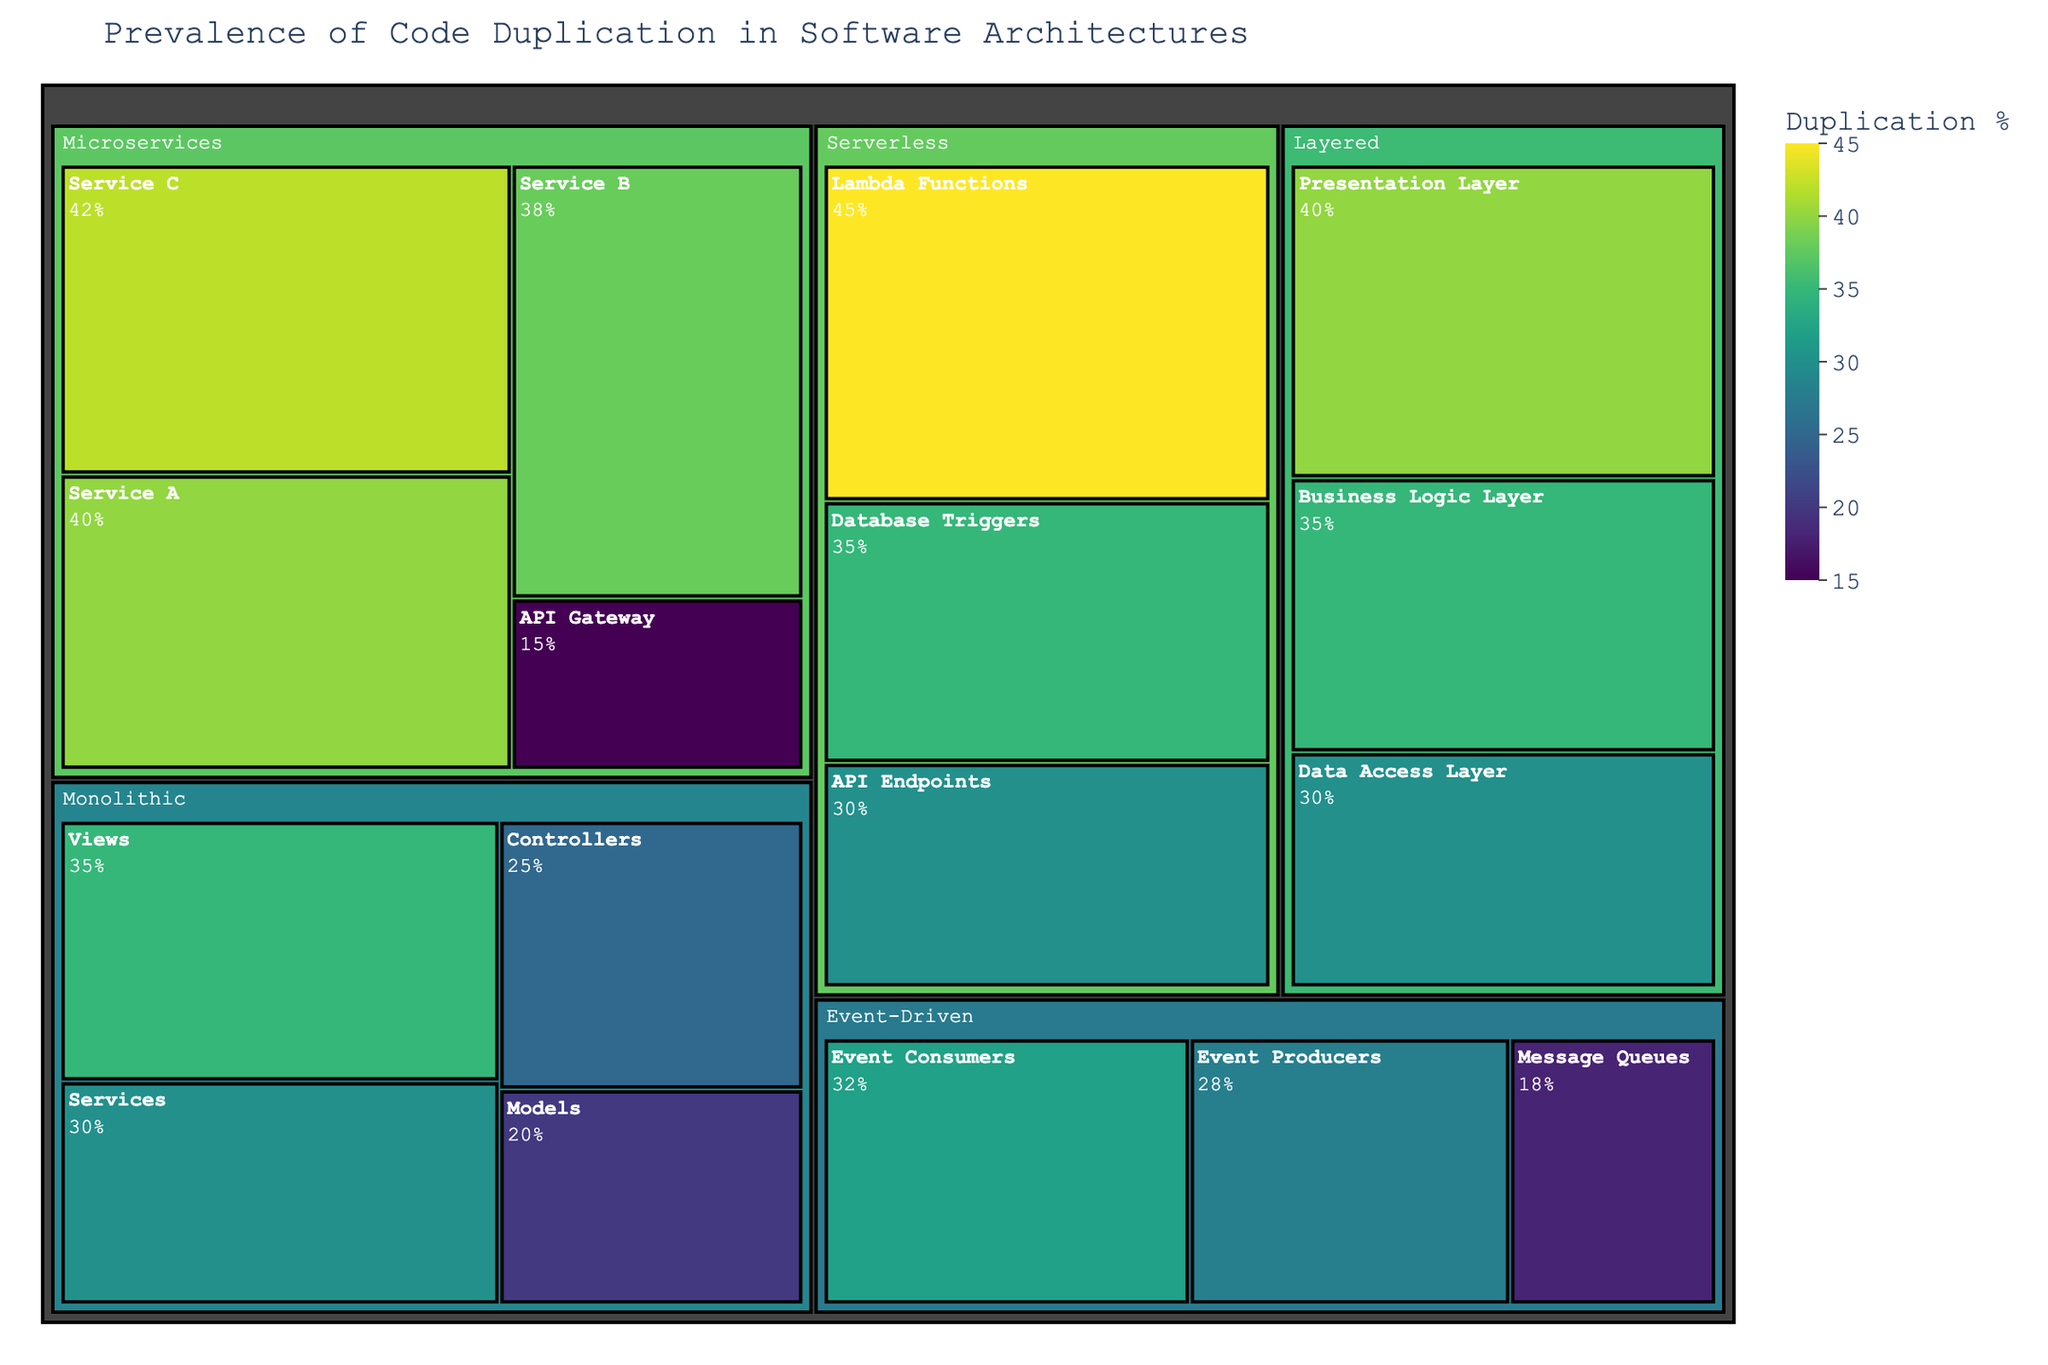What is the title of the Treemap? The title is located at the top of the treemap. It summarizes the main subject of the visualization. The title is "Prevalence of Code Duplication in Software Architectures".
Answer: Prevalence of Code Duplication in Software Architectures Which architectural component has the highest duplication percentage? By looking at the color intensity (darker shade) and value, we see that "Lambda Functions" under "Serverless" architecture has the highest duplication percentage. It shows a value of 45%.
Answer: Lambda Functions How many architectural components are in the Monolithic architecture? By checking the paths under the Monolithic architecture, we can count the components listed: Controllers, Services, Models, and Views, totaling to 4.
Answer: 4 What is the average duplication percentage for the Microservices architecture? Calculate the average of the duplication percentages for API Gateway, Service A, Service B, and Service C: (15 + 40 + 38 + 42) / 4 = 135 / 4 = 33.75%.
Answer: 33.75% Which architectures have at least one component with exactly 35% duplication? By examining the treemap, both "Monolithic" has "Views" and "Layered" has "Business Logic Layer" that show 35% duplication each.
Answer: Monolithic, Layered Which component in the Event-Driven architecture has the lowest duplication percentage and what is it? In the Event-Driven architecture, check the values for Event Producers, Event Consumers, and Message Queues. Message Queues shows the lowest value with 18%.
Answer: Message Queues, 18% Compare the duplication percentage of Services in Monolithic with Service A in Microservices. Which one is higher? The Services component in Monolithic shows 30% duplication and Service A in Microservices shows 40%. Hence, Service A has a higher duplication percentage.
Answer: Service A Considering all the components in the Layered architecture, what is their total duplication percentage? Sum the duplication percentages: Presentation Layer (40%) + Business Logic Layer (35%) + Data Access Layer (30%) = 40 + 35 + 30 = 105%
Answer: 105% What is the duplication percentage difference between API Gateway in Microservices and API Endpoints in Serverless? Subtract the duplication percentage of API Gateway (15%) in Microservices from API Endpoints (30%) in Serverless: 30% - 15% = 15%.
Answer: 15% Which architecture, between Monolithic and Serverless, has a higher average duplication percentage across all components? For Monolithic: (25 + 30 + 20 + 35) / 4 = 27.5%. For Serverless: (45 + 30 + 35) / 3 = 36.67%. Serverless has the higher average.
Answer: Serverless 